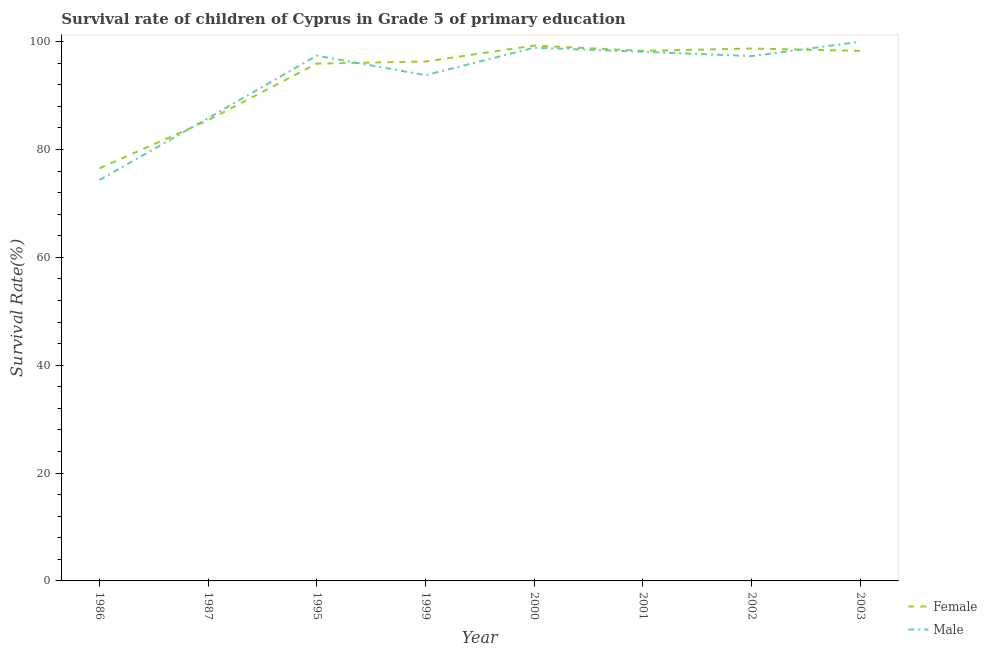Does the line corresponding to survival rate of female students in primary education intersect with the line corresponding to survival rate of male students in primary education?
Give a very brief answer. Yes. What is the survival rate of female students in primary education in 1999?
Give a very brief answer. 96.31. Across all years, what is the maximum survival rate of male students in primary education?
Make the answer very short. 99.97. Across all years, what is the minimum survival rate of male students in primary education?
Your response must be concise. 74.33. What is the total survival rate of male students in primary education in the graph?
Provide a short and direct response. 745.66. What is the difference between the survival rate of male students in primary education in 1987 and that in 2003?
Your answer should be compact. -14.15. What is the difference between the survival rate of female students in primary education in 1987 and the survival rate of male students in primary education in 2001?
Provide a succinct answer. -12.71. What is the average survival rate of male students in primary education per year?
Your response must be concise. 93.21. In the year 2000, what is the difference between the survival rate of male students in primary education and survival rate of female students in primary education?
Your response must be concise. -0.4. What is the ratio of the survival rate of female students in primary education in 1986 to that in 2002?
Your answer should be compact. 0.77. Is the survival rate of male students in primary education in 1987 less than that in 2003?
Make the answer very short. Yes. Is the difference between the survival rate of male students in primary education in 1987 and 2001 greater than the difference between the survival rate of female students in primary education in 1987 and 2001?
Keep it short and to the point. Yes. What is the difference between the highest and the second highest survival rate of male students in primary education?
Your response must be concise. 1.1. What is the difference between the highest and the lowest survival rate of female students in primary education?
Give a very brief answer. 22.76. Does the survival rate of male students in primary education monotonically increase over the years?
Your answer should be very brief. No. Is the survival rate of female students in primary education strictly less than the survival rate of male students in primary education over the years?
Ensure brevity in your answer.  No. How many years are there in the graph?
Give a very brief answer. 8. Does the graph contain any zero values?
Provide a short and direct response. No. How are the legend labels stacked?
Offer a very short reply. Vertical. What is the title of the graph?
Ensure brevity in your answer.  Survival rate of children of Cyprus in Grade 5 of primary education. What is the label or title of the Y-axis?
Give a very brief answer. Survival Rate(%). What is the Survival Rate(%) in Female in 1986?
Your answer should be compact. 76.51. What is the Survival Rate(%) in Male in 1986?
Provide a short and direct response. 74.33. What is the Survival Rate(%) of Female in 1987?
Make the answer very short. 85.43. What is the Survival Rate(%) in Male in 1987?
Offer a terse response. 85.83. What is the Survival Rate(%) in Female in 1995?
Provide a short and direct response. 95.94. What is the Survival Rate(%) in Male in 1995?
Provide a succinct answer. 97.41. What is the Survival Rate(%) in Female in 1999?
Offer a terse response. 96.31. What is the Survival Rate(%) in Male in 1999?
Keep it short and to the point. 93.79. What is the Survival Rate(%) in Female in 2000?
Your response must be concise. 99.27. What is the Survival Rate(%) in Male in 2000?
Ensure brevity in your answer.  98.88. What is the Survival Rate(%) in Female in 2001?
Ensure brevity in your answer.  98.29. What is the Survival Rate(%) of Male in 2001?
Your answer should be very brief. 98.13. What is the Survival Rate(%) in Female in 2002?
Ensure brevity in your answer.  98.72. What is the Survival Rate(%) in Male in 2002?
Offer a terse response. 97.32. What is the Survival Rate(%) of Female in 2003?
Make the answer very short. 98.29. What is the Survival Rate(%) of Male in 2003?
Your answer should be compact. 99.97. Across all years, what is the maximum Survival Rate(%) of Female?
Offer a terse response. 99.27. Across all years, what is the maximum Survival Rate(%) in Male?
Your answer should be very brief. 99.97. Across all years, what is the minimum Survival Rate(%) of Female?
Your answer should be compact. 76.51. Across all years, what is the minimum Survival Rate(%) in Male?
Your response must be concise. 74.33. What is the total Survival Rate(%) in Female in the graph?
Provide a short and direct response. 748.77. What is the total Survival Rate(%) of Male in the graph?
Offer a terse response. 745.66. What is the difference between the Survival Rate(%) in Female in 1986 and that in 1987?
Offer a very short reply. -8.92. What is the difference between the Survival Rate(%) of Male in 1986 and that in 1987?
Offer a very short reply. -11.49. What is the difference between the Survival Rate(%) of Female in 1986 and that in 1995?
Offer a terse response. -19.43. What is the difference between the Survival Rate(%) in Male in 1986 and that in 1995?
Keep it short and to the point. -23.08. What is the difference between the Survival Rate(%) of Female in 1986 and that in 1999?
Provide a short and direct response. -19.8. What is the difference between the Survival Rate(%) in Male in 1986 and that in 1999?
Provide a short and direct response. -19.45. What is the difference between the Survival Rate(%) of Female in 1986 and that in 2000?
Provide a short and direct response. -22.76. What is the difference between the Survival Rate(%) in Male in 1986 and that in 2000?
Make the answer very short. -24.54. What is the difference between the Survival Rate(%) of Female in 1986 and that in 2001?
Provide a succinct answer. -21.78. What is the difference between the Survival Rate(%) of Male in 1986 and that in 2001?
Give a very brief answer. -23.8. What is the difference between the Survival Rate(%) in Female in 1986 and that in 2002?
Offer a terse response. -22.21. What is the difference between the Survival Rate(%) of Male in 1986 and that in 2002?
Offer a very short reply. -22.99. What is the difference between the Survival Rate(%) in Female in 1986 and that in 2003?
Provide a succinct answer. -21.78. What is the difference between the Survival Rate(%) of Male in 1986 and that in 2003?
Offer a terse response. -25.64. What is the difference between the Survival Rate(%) in Female in 1987 and that in 1995?
Your answer should be compact. -10.51. What is the difference between the Survival Rate(%) of Male in 1987 and that in 1995?
Make the answer very short. -11.58. What is the difference between the Survival Rate(%) in Female in 1987 and that in 1999?
Give a very brief answer. -10.89. What is the difference between the Survival Rate(%) in Male in 1987 and that in 1999?
Offer a very short reply. -7.96. What is the difference between the Survival Rate(%) in Female in 1987 and that in 2000?
Your answer should be very brief. -13.85. What is the difference between the Survival Rate(%) in Male in 1987 and that in 2000?
Provide a short and direct response. -13.05. What is the difference between the Survival Rate(%) of Female in 1987 and that in 2001?
Provide a succinct answer. -12.87. What is the difference between the Survival Rate(%) of Male in 1987 and that in 2001?
Ensure brevity in your answer.  -12.31. What is the difference between the Survival Rate(%) in Female in 1987 and that in 2002?
Ensure brevity in your answer.  -13.3. What is the difference between the Survival Rate(%) of Male in 1987 and that in 2002?
Your answer should be very brief. -11.49. What is the difference between the Survival Rate(%) of Female in 1987 and that in 2003?
Make the answer very short. -12.87. What is the difference between the Survival Rate(%) of Male in 1987 and that in 2003?
Your answer should be compact. -14.15. What is the difference between the Survival Rate(%) in Female in 1995 and that in 1999?
Keep it short and to the point. -0.38. What is the difference between the Survival Rate(%) in Male in 1995 and that in 1999?
Give a very brief answer. 3.63. What is the difference between the Survival Rate(%) in Female in 1995 and that in 2000?
Offer a very short reply. -3.34. What is the difference between the Survival Rate(%) of Male in 1995 and that in 2000?
Your response must be concise. -1.46. What is the difference between the Survival Rate(%) of Female in 1995 and that in 2001?
Provide a short and direct response. -2.36. What is the difference between the Survival Rate(%) in Male in 1995 and that in 2001?
Provide a succinct answer. -0.72. What is the difference between the Survival Rate(%) in Female in 1995 and that in 2002?
Make the answer very short. -2.79. What is the difference between the Survival Rate(%) in Male in 1995 and that in 2002?
Offer a very short reply. 0.09. What is the difference between the Survival Rate(%) in Female in 1995 and that in 2003?
Your answer should be compact. -2.36. What is the difference between the Survival Rate(%) in Male in 1995 and that in 2003?
Make the answer very short. -2.56. What is the difference between the Survival Rate(%) of Female in 1999 and that in 2000?
Offer a very short reply. -2.96. What is the difference between the Survival Rate(%) of Male in 1999 and that in 2000?
Offer a terse response. -5.09. What is the difference between the Survival Rate(%) of Female in 1999 and that in 2001?
Offer a terse response. -1.98. What is the difference between the Survival Rate(%) of Male in 1999 and that in 2001?
Offer a terse response. -4.35. What is the difference between the Survival Rate(%) in Female in 1999 and that in 2002?
Provide a succinct answer. -2.41. What is the difference between the Survival Rate(%) of Male in 1999 and that in 2002?
Provide a succinct answer. -3.54. What is the difference between the Survival Rate(%) of Female in 1999 and that in 2003?
Keep it short and to the point. -1.98. What is the difference between the Survival Rate(%) in Male in 1999 and that in 2003?
Your answer should be very brief. -6.19. What is the difference between the Survival Rate(%) of Female in 2000 and that in 2001?
Your response must be concise. 0.98. What is the difference between the Survival Rate(%) of Male in 2000 and that in 2001?
Give a very brief answer. 0.74. What is the difference between the Survival Rate(%) in Female in 2000 and that in 2002?
Your response must be concise. 0.55. What is the difference between the Survival Rate(%) of Male in 2000 and that in 2002?
Ensure brevity in your answer.  1.55. What is the difference between the Survival Rate(%) in Female in 2000 and that in 2003?
Offer a terse response. 0.98. What is the difference between the Survival Rate(%) in Male in 2000 and that in 2003?
Your answer should be very brief. -1.1. What is the difference between the Survival Rate(%) of Female in 2001 and that in 2002?
Your response must be concise. -0.43. What is the difference between the Survival Rate(%) of Male in 2001 and that in 2002?
Offer a very short reply. 0.81. What is the difference between the Survival Rate(%) in Female in 2001 and that in 2003?
Ensure brevity in your answer.  -0. What is the difference between the Survival Rate(%) in Male in 2001 and that in 2003?
Give a very brief answer. -1.84. What is the difference between the Survival Rate(%) of Female in 2002 and that in 2003?
Ensure brevity in your answer.  0.43. What is the difference between the Survival Rate(%) in Male in 2002 and that in 2003?
Ensure brevity in your answer.  -2.65. What is the difference between the Survival Rate(%) in Female in 1986 and the Survival Rate(%) in Male in 1987?
Your response must be concise. -9.32. What is the difference between the Survival Rate(%) of Female in 1986 and the Survival Rate(%) of Male in 1995?
Your answer should be very brief. -20.9. What is the difference between the Survival Rate(%) of Female in 1986 and the Survival Rate(%) of Male in 1999?
Offer a terse response. -17.28. What is the difference between the Survival Rate(%) of Female in 1986 and the Survival Rate(%) of Male in 2000?
Provide a succinct answer. -22.36. What is the difference between the Survival Rate(%) of Female in 1986 and the Survival Rate(%) of Male in 2001?
Ensure brevity in your answer.  -21.62. What is the difference between the Survival Rate(%) in Female in 1986 and the Survival Rate(%) in Male in 2002?
Your answer should be very brief. -20.81. What is the difference between the Survival Rate(%) in Female in 1986 and the Survival Rate(%) in Male in 2003?
Offer a terse response. -23.46. What is the difference between the Survival Rate(%) in Female in 1987 and the Survival Rate(%) in Male in 1995?
Ensure brevity in your answer.  -11.98. What is the difference between the Survival Rate(%) in Female in 1987 and the Survival Rate(%) in Male in 1999?
Offer a very short reply. -8.36. What is the difference between the Survival Rate(%) of Female in 1987 and the Survival Rate(%) of Male in 2000?
Provide a short and direct response. -13.45. What is the difference between the Survival Rate(%) in Female in 1987 and the Survival Rate(%) in Male in 2001?
Provide a succinct answer. -12.71. What is the difference between the Survival Rate(%) in Female in 1987 and the Survival Rate(%) in Male in 2002?
Give a very brief answer. -11.89. What is the difference between the Survival Rate(%) in Female in 1987 and the Survival Rate(%) in Male in 2003?
Make the answer very short. -14.55. What is the difference between the Survival Rate(%) of Female in 1995 and the Survival Rate(%) of Male in 1999?
Provide a short and direct response. 2.15. What is the difference between the Survival Rate(%) of Female in 1995 and the Survival Rate(%) of Male in 2000?
Give a very brief answer. -2.94. What is the difference between the Survival Rate(%) in Female in 1995 and the Survival Rate(%) in Male in 2001?
Provide a succinct answer. -2.2. What is the difference between the Survival Rate(%) of Female in 1995 and the Survival Rate(%) of Male in 2002?
Offer a terse response. -1.39. What is the difference between the Survival Rate(%) of Female in 1995 and the Survival Rate(%) of Male in 2003?
Provide a short and direct response. -4.04. What is the difference between the Survival Rate(%) of Female in 1999 and the Survival Rate(%) of Male in 2000?
Keep it short and to the point. -2.56. What is the difference between the Survival Rate(%) of Female in 1999 and the Survival Rate(%) of Male in 2001?
Offer a very short reply. -1.82. What is the difference between the Survival Rate(%) in Female in 1999 and the Survival Rate(%) in Male in 2002?
Your response must be concise. -1.01. What is the difference between the Survival Rate(%) in Female in 1999 and the Survival Rate(%) in Male in 2003?
Provide a short and direct response. -3.66. What is the difference between the Survival Rate(%) in Female in 2000 and the Survival Rate(%) in Male in 2001?
Make the answer very short. 1.14. What is the difference between the Survival Rate(%) of Female in 2000 and the Survival Rate(%) of Male in 2002?
Your answer should be compact. 1.95. What is the difference between the Survival Rate(%) of Female in 2000 and the Survival Rate(%) of Male in 2003?
Ensure brevity in your answer.  -0.7. What is the difference between the Survival Rate(%) in Female in 2001 and the Survival Rate(%) in Male in 2002?
Provide a short and direct response. 0.97. What is the difference between the Survival Rate(%) in Female in 2001 and the Survival Rate(%) in Male in 2003?
Offer a terse response. -1.68. What is the difference between the Survival Rate(%) of Female in 2002 and the Survival Rate(%) of Male in 2003?
Your answer should be very brief. -1.25. What is the average Survival Rate(%) in Female per year?
Give a very brief answer. 93.6. What is the average Survival Rate(%) in Male per year?
Your response must be concise. 93.21. In the year 1986, what is the difference between the Survival Rate(%) of Female and Survival Rate(%) of Male?
Your answer should be compact. 2.18. In the year 1987, what is the difference between the Survival Rate(%) in Female and Survival Rate(%) in Male?
Offer a very short reply. -0.4. In the year 1995, what is the difference between the Survival Rate(%) in Female and Survival Rate(%) in Male?
Give a very brief answer. -1.48. In the year 1999, what is the difference between the Survival Rate(%) in Female and Survival Rate(%) in Male?
Your answer should be compact. 2.53. In the year 2000, what is the difference between the Survival Rate(%) in Female and Survival Rate(%) in Male?
Your answer should be compact. 0.4. In the year 2001, what is the difference between the Survival Rate(%) in Female and Survival Rate(%) in Male?
Your response must be concise. 0.16. In the year 2002, what is the difference between the Survival Rate(%) in Female and Survival Rate(%) in Male?
Ensure brevity in your answer.  1.4. In the year 2003, what is the difference between the Survival Rate(%) of Female and Survival Rate(%) of Male?
Give a very brief answer. -1.68. What is the ratio of the Survival Rate(%) of Female in 1986 to that in 1987?
Give a very brief answer. 0.9. What is the ratio of the Survival Rate(%) in Male in 1986 to that in 1987?
Ensure brevity in your answer.  0.87. What is the ratio of the Survival Rate(%) of Female in 1986 to that in 1995?
Offer a terse response. 0.8. What is the ratio of the Survival Rate(%) in Male in 1986 to that in 1995?
Provide a short and direct response. 0.76. What is the ratio of the Survival Rate(%) of Female in 1986 to that in 1999?
Offer a very short reply. 0.79. What is the ratio of the Survival Rate(%) in Male in 1986 to that in 1999?
Make the answer very short. 0.79. What is the ratio of the Survival Rate(%) in Female in 1986 to that in 2000?
Provide a short and direct response. 0.77. What is the ratio of the Survival Rate(%) of Male in 1986 to that in 2000?
Offer a terse response. 0.75. What is the ratio of the Survival Rate(%) of Female in 1986 to that in 2001?
Give a very brief answer. 0.78. What is the ratio of the Survival Rate(%) in Male in 1986 to that in 2001?
Keep it short and to the point. 0.76. What is the ratio of the Survival Rate(%) in Female in 1986 to that in 2002?
Make the answer very short. 0.78. What is the ratio of the Survival Rate(%) of Male in 1986 to that in 2002?
Provide a short and direct response. 0.76. What is the ratio of the Survival Rate(%) of Female in 1986 to that in 2003?
Your answer should be compact. 0.78. What is the ratio of the Survival Rate(%) of Male in 1986 to that in 2003?
Provide a short and direct response. 0.74. What is the ratio of the Survival Rate(%) of Female in 1987 to that in 1995?
Ensure brevity in your answer.  0.89. What is the ratio of the Survival Rate(%) in Male in 1987 to that in 1995?
Ensure brevity in your answer.  0.88. What is the ratio of the Survival Rate(%) in Female in 1987 to that in 1999?
Offer a very short reply. 0.89. What is the ratio of the Survival Rate(%) of Male in 1987 to that in 1999?
Your answer should be compact. 0.92. What is the ratio of the Survival Rate(%) of Female in 1987 to that in 2000?
Make the answer very short. 0.86. What is the ratio of the Survival Rate(%) of Male in 1987 to that in 2000?
Give a very brief answer. 0.87. What is the ratio of the Survival Rate(%) in Female in 1987 to that in 2001?
Your response must be concise. 0.87. What is the ratio of the Survival Rate(%) of Male in 1987 to that in 2001?
Your answer should be very brief. 0.87. What is the ratio of the Survival Rate(%) in Female in 1987 to that in 2002?
Offer a very short reply. 0.87. What is the ratio of the Survival Rate(%) of Male in 1987 to that in 2002?
Your response must be concise. 0.88. What is the ratio of the Survival Rate(%) in Female in 1987 to that in 2003?
Make the answer very short. 0.87. What is the ratio of the Survival Rate(%) in Male in 1987 to that in 2003?
Make the answer very short. 0.86. What is the ratio of the Survival Rate(%) of Female in 1995 to that in 1999?
Your answer should be compact. 1. What is the ratio of the Survival Rate(%) in Male in 1995 to that in 1999?
Ensure brevity in your answer.  1.04. What is the ratio of the Survival Rate(%) in Female in 1995 to that in 2000?
Offer a very short reply. 0.97. What is the ratio of the Survival Rate(%) of Male in 1995 to that in 2000?
Your answer should be compact. 0.99. What is the ratio of the Survival Rate(%) in Female in 1995 to that in 2001?
Make the answer very short. 0.98. What is the ratio of the Survival Rate(%) in Female in 1995 to that in 2002?
Your response must be concise. 0.97. What is the ratio of the Survival Rate(%) in Male in 1995 to that in 2002?
Offer a very short reply. 1. What is the ratio of the Survival Rate(%) of Male in 1995 to that in 2003?
Offer a terse response. 0.97. What is the ratio of the Survival Rate(%) of Female in 1999 to that in 2000?
Your response must be concise. 0.97. What is the ratio of the Survival Rate(%) in Male in 1999 to that in 2000?
Your response must be concise. 0.95. What is the ratio of the Survival Rate(%) in Female in 1999 to that in 2001?
Keep it short and to the point. 0.98. What is the ratio of the Survival Rate(%) in Male in 1999 to that in 2001?
Provide a short and direct response. 0.96. What is the ratio of the Survival Rate(%) of Female in 1999 to that in 2002?
Your response must be concise. 0.98. What is the ratio of the Survival Rate(%) in Male in 1999 to that in 2002?
Offer a very short reply. 0.96. What is the ratio of the Survival Rate(%) in Female in 1999 to that in 2003?
Your response must be concise. 0.98. What is the ratio of the Survival Rate(%) in Male in 1999 to that in 2003?
Your answer should be compact. 0.94. What is the ratio of the Survival Rate(%) in Male in 2000 to that in 2001?
Keep it short and to the point. 1.01. What is the ratio of the Survival Rate(%) in Female in 2000 to that in 2002?
Provide a short and direct response. 1.01. What is the ratio of the Survival Rate(%) of Male in 2000 to that in 2002?
Your answer should be compact. 1.02. What is the ratio of the Survival Rate(%) of Male in 2001 to that in 2002?
Provide a short and direct response. 1.01. What is the ratio of the Survival Rate(%) of Female in 2001 to that in 2003?
Offer a terse response. 1. What is the ratio of the Survival Rate(%) of Male in 2001 to that in 2003?
Your answer should be compact. 0.98. What is the ratio of the Survival Rate(%) in Female in 2002 to that in 2003?
Offer a terse response. 1. What is the ratio of the Survival Rate(%) of Male in 2002 to that in 2003?
Provide a succinct answer. 0.97. What is the difference between the highest and the second highest Survival Rate(%) of Female?
Provide a short and direct response. 0.55. What is the difference between the highest and the second highest Survival Rate(%) of Male?
Your answer should be very brief. 1.1. What is the difference between the highest and the lowest Survival Rate(%) of Female?
Provide a succinct answer. 22.76. What is the difference between the highest and the lowest Survival Rate(%) of Male?
Your answer should be very brief. 25.64. 